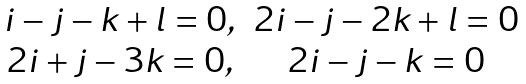<formula> <loc_0><loc_0><loc_500><loc_500>\begin{array} { c c } i - j - k + l = 0 , & 2 i - j - 2 k + l = 0 \\ 2 i + j - 3 k = 0 , & 2 i - j - k = 0 \end{array}</formula> 